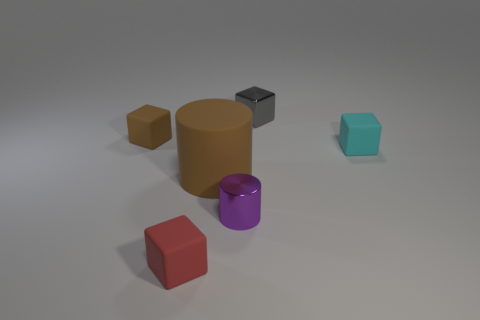Is there any other thing that is the same size as the brown matte cylinder?
Offer a terse response. No. What shape is the small purple thing?
Ensure brevity in your answer.  Cylinder. Are there the same number of small matte cubes behind the brown cylinder and small gray metal things left of the tiny cyan block?
Your response must be concise. No. There is a cylinder that is on the left side of the purple cylinder; is its color the same as the tiny rubber object that is right of the large matte thing?
Your answer should be very brief. No. Are there more large matte cylinders that are behind the small cyan matte cube than cyan balls?
Provide a short and direct response. No. What is the shape of the other brown object that is the same material as the small brown object?
Your response must be concise. Cylinder. Does the matte cube that is left of the red thing have the same size as the purple shiny cylinder?
Offer a terse response. Yes. What shape is the small matte object on the right side of the tiny cube in front of the big rubber cylinder?
Your answer should be very brief. Cube. There is a brown thing to the right of the tiny rubber block in front of the big brown matte object; how big is it?
Ensure brevity in your answer.  Large. The metal object that is in front of the gray shiny object is what color?
Offer a very short reply. Purple. 